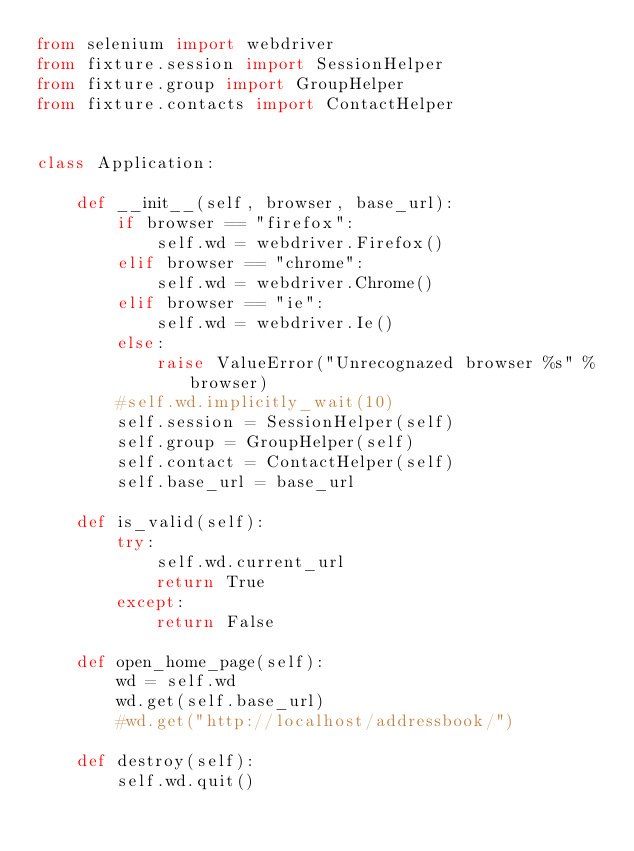<code> <loc_0><loc_0><loc_500><loc_500><_Python_>from selenium import webdriver
from fixture.session import SessionHelper
from fixture.group import GroupHelper
from fixture.contacts import ContactHelper


class Application:

    def __init__(self, browser, base_url):
        if browser == "firefox":
            self.wd = webdriver.Firefox()
        elif browser == "chrome":
            self.wd = webdriver.Chrome()
        elif browser == "ie":
            self.wd = webdriver.Ie()
        else:
            raise ValueError("Unrecognazed browser %s" % browser)
        #self.wd.implicitly_wait(10)
        self.session = SessionHelper(self)
        self.group = GroupHelper(self)
        self.contact = ContactHelper(self)
        self.base_url = base_url

    def is_valid(self):
        try:
            self.wd.current_url
            return True
        except:
            return False

    def open_home_page(self):
        wd = self.wd
        wd.get(self.base_url)
        #wd.get("http://localhost/addressbook/")

    def destroy(self):
        self.wd.quit()</code> 